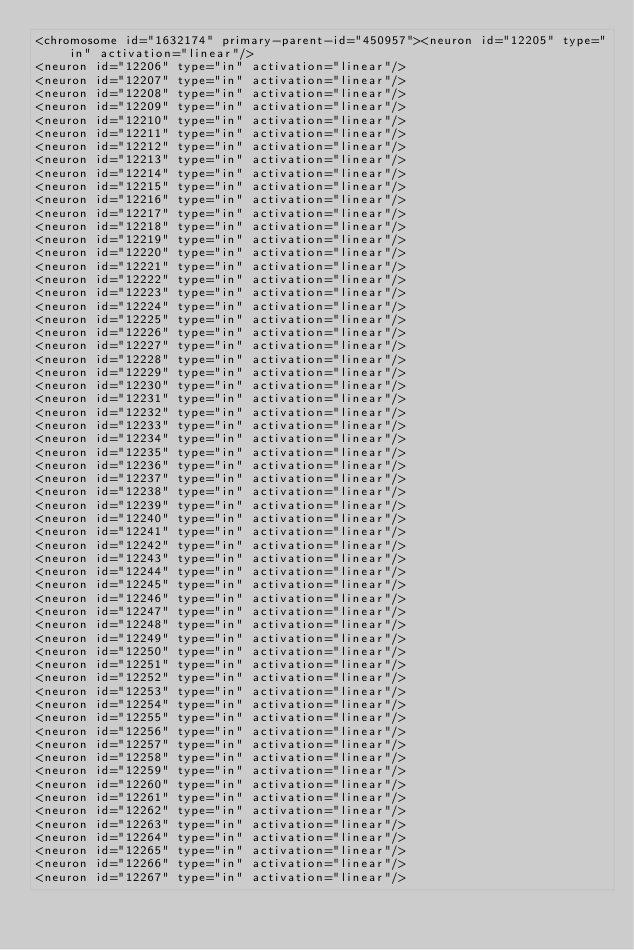Convert code to text. <code><loc_0><loc_0><loc_500><loc_500><_XML_><chromosome id="1632174" primary-parent-id="450957"><neuron id="12205" type="in" activation="linear"/>
<neuron id="12206" type="in" activation="linear"/>
<neuron id="12207" type="in" activation="linear"/>
<neuron id="12208" type="in" activation="linear"/>
<neuron id="12209" type="in" activation="linear"/>
<neuron id="12210" type="in" activation="linear"/>
<neuron id="12211" type="in" activation="linear"/>
<neuron id="12212" type="in" activation="linear"/>
<neuron id="12213" type="in" activation="linear"/>
<neuron id="12214" type="in" activation="linear"/>
<neuron id="12215" type="in" activation="linear"/>
<neuron id="12216" type="in" activation="linear"/>
<neuron id="12217" type="in" activation="linear"/>
<neuron id="12218" type="in" activation="linear"/>
<neuron id="12219" type="in" activation="linear"/>
<neuron id="12220" type="in" activation="linear"/>
<neuron id="12221" type="in" activation="linear"/>
<neuron id="12222" type="in" activation="linear"/>
<neuron id="12223" type="in" activation="linear"/>
<neuron id="12224" type="in" activation="linear"/>
<neuron id="12225" type="in" activation="linear"/>
<neuron id="12226" type="in" activation="linear"/>
<neuron id="12227" type="in" activation="linear"/>
<neuron id="12228" type="in" activation="linear"/>
<neuron id="12229" type="in" activation="linear"/>
<neuron id="12230" type="in" activation="linear"/>
<neuron id="12231" type="in" activation="linear"/>
<neuron id="12232" type="in" activation="linear"/>
<neuron id="12233" type="in" activation="linear"/>
<neuron id="12234" type="in" activation="linear"/>
<neuron id="12235" type="in" activation="linear"/>
<neuron id="12236" type="in" activation="linear"/>
<neuron id="12237" type="in" activation="linear"/>
<neuron id="12238" type="in" activation="linear"/>
<neuron id="12239" type="in" activation="linear"/>
<neuron id="12240" type="in" activation="linear"/>
<neuron id="12241" type="in" activation="linear"/>
<neuron id="12242" type="in" activation="linear"/>
<neuron id="12243" type="in" activation="linear"/>
<neuron id="12244" type="in" activation="linear"/>
<neuron id="12245" type="in" activation="linear"/>
<neuron id="12246" type="in" activation="linear"/>
<neuron id="12247" type="in" activation="linear"/>
<neuron id="12248" type="in" activation="linear"/>
<neuron id="12249" type="in" activation="linear"/>
<neuron id="12250" type="in" activation="linear"/>
<neuron id="12251" type="in" activation="linear"/>
<neuron id="12252" type="in" activation="linear"/>
<neuron id="12253" type="in" activation="linear"/>
<neuron id="12254" type="in" activation="linear"/>
<neuron id="12255" type="in" activation="linear"/>
<neuron id="12256" type="in" activation="linear"/>
<neuron id="12257" type="in" activation="linear"/>
<neuron id="12258" type="in" activation="linear"/>
<neuron id="12259" type="in" activation="linear"/>
<neuron id="12260" type="in" activation="linear"/>
<neuron id="12261" type="in" activation="linear"/>
<neuron id="12262" type="in" activation="linear"/>
<neuron id="12263" type="in" activation="linear"/>
<neuron id="12264" type="in" activation="linear"/>
<neuron id="12265" type="in" activation="linear"/>
<neuron id="12266" type="in" activation="linear"/>
<neuron id="12267" type="in" activation="linear"/></code> 